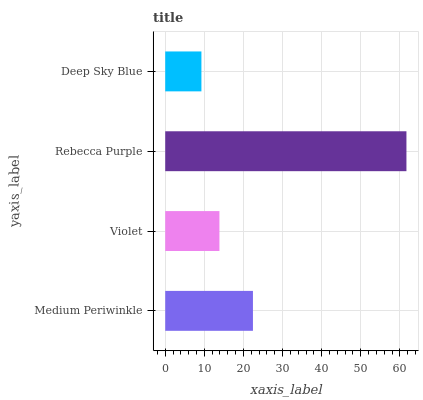Is Deep Sky Blue the minimum?
Answer yes or no. Yes. Is Rebecca Purple the maximum?
Answer yes or no. Yes. Is Violet the minimum?
Answer yes or no. No. Is Violet the maximum?
Answer yes or no. No. Is Medium Periwinkle greater than Violet?
Answer yes or no. Yes. Is Violet less than Medium Periwinkle?
Answer yes or no. Yes. Is Violet greater than Medium Periwinkle?
Answer yes or no. No. Is Medium Periwinkle less than Violet?
Answer yes or no. No. Is Medium Periwinkle the high median?
Answer yes or no. Yes. Is Violet the low median?
Answer yes or no. Yes. Is Deep Sky Blue the high median?
Answer yes or no. No. Is Rebecca Purple the low median?
Answer yes or no. No. 